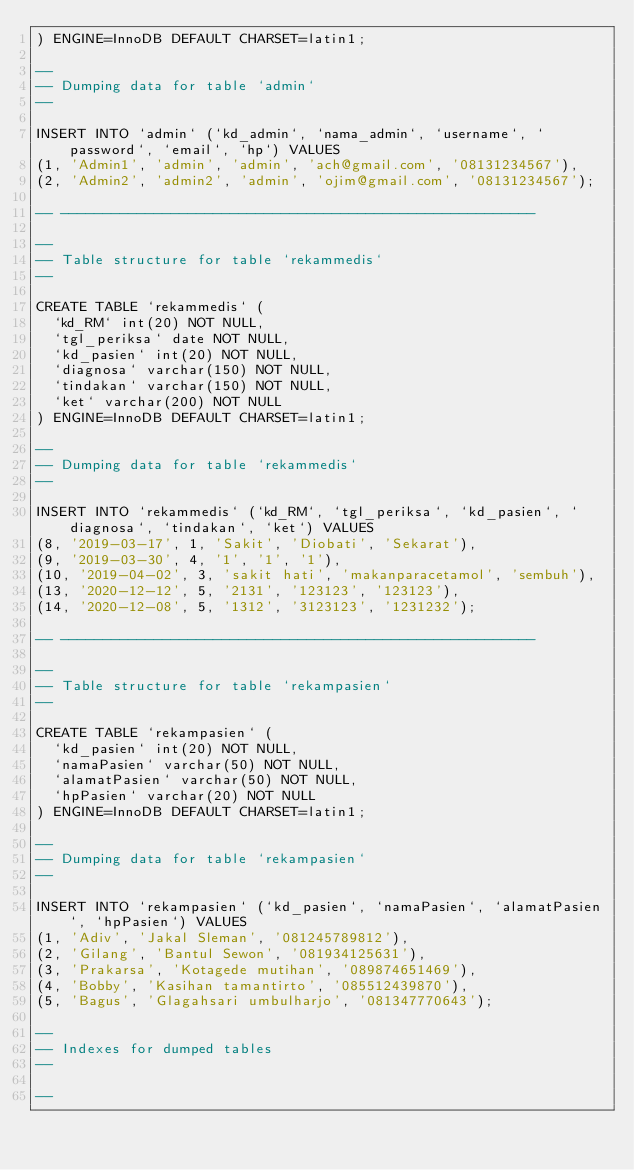<code> <loc_0><loc_0><loc_500><loc_500><_SQL_>) ENGINE=InnoDB DEFAULT CHARSET=latin1;

--
-- Dumping data for table `admin`
--

INSERT INTO `admin` (`kd_admin`, `nama_admin`, `username`, `password`, `email`, `hp`) VALUES
(1, 'Admin1', 'admin', 'admin', 'ach@gmail.com', '08131234567'),
(2, 'Admin2', 'admin2', 'admin', 'ojim@gmail.com', '08131234567');

-- --------------------------------------------------------

--
-- Table structure for table `rekammedis`
--

CREATE TABLE `rekammedis` (
  `kd_RM` int(20) NOT NULL,
  `tgl_periksa` date NOT NULL,
  `kd_pasien` int(20) NOT NULL,
  `diagnosa` varchar(150) NOT NULL,
  `tindakan` varchar(150) NOT NULL,
  `ket` varchar(200) NOT NULL
) ENGINE=InnoDB DEFAULT CHARSET=latin1;

--
-- Dumping data for table `rekammedis`
--

INSERT INTO `rekammedis` (`kd_RM`, `tgl_periksa`, `kd_pasien`, `diagnosa`, `tindakan`, `ket`) VALUES
(8, '2019-03-17', 1, 'Sakit', 'Diobati', 'Sekarat'),
(9, '2019-03-30', 4, '1', '1', '1'),
(10, '2019-04-02', 3, 'sakit hati', 'makanparacetamol', 'sembuh'),
(13, '2020-12-12', 5, '2131', '123123', '123123'),
(14, '2020-12-08', 5, '1312', '3123123', '1231232');

-- --------------------------------------------------------

--
-- Table structure for table `rekampasien`
--

CREATE TABLE `rekampasien` (
  `kd_pasien` int(20) NOT NULL,
  `namaPasien` varchar(50) NOT NULL,
  `alamatPasien` varchar(50) NOT NULL,
  `hpPasien` varchar(20) NOT NULL
) ENGINE=InnoDB DEFAULT CHARSET=latin1;

--
-- Dumping data for table `rekampasien`
--

INSERT INTO `rekampasien` (`kd_pasien`, `namaPasien`, `alamatPasien`, `hpPasien`) VALUES
(1, 'Adiv', 'Jakal Sleman', '081245789812'),
(2, 'Gilang', 'Bantul Sewon', '081934125631'),
(3, 'Prakarsa', 'Kotagede mutihan', '089874651469'),
(4, 'Bobby', 'Kasihan tamantirto', '085512439870'),
(5, 'Bagus', 'Glagahsari umbulharjo', '081347770643');

--
-- Indexes for dumped tables
--

--</code> 